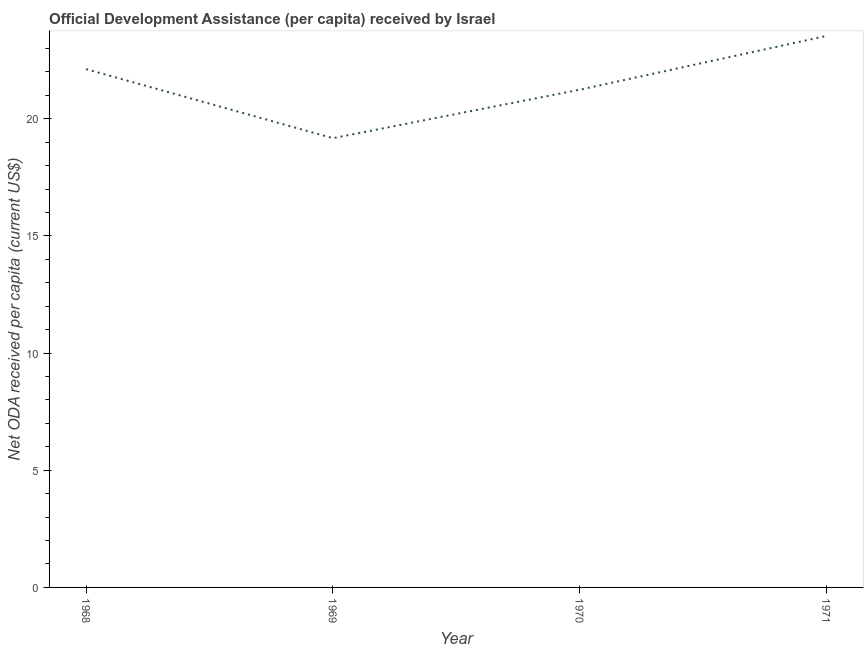What is the net oda received per capita in 1970?
Your response must be concise. 21.24. Across all years, what is the maximum net oda received per capita?
Give a very brief answer. 23.53. Across all years, what is the minimum net oda received per capita?
Give a very brief answer. 19.17. In which year was the net oda received per capita maximum?
Keep it short and to the point. 1971. In which year was the net oda received per capita minimum?
Offer a very short reply. 1969. What is the sum of the net oda received per capita?
Offer a terse response. 86.05. What is the difference between the net oda received per capita in 1969 and 1970?
Ensure brevity in your answer.  -2.07. What is the average net oda received per capita per year?
Offer a very short reply. 21.51. What is the median net oda received per capita?
Your answer should be compact. 21.68. In how many years, is the net oda received per capita greater than 1 US$?
Ensure brevity in your answer.  4. What is the ratio of the net oda received per capita in 1969 to that in 1970?
Your response must be concise. 0.9. What is the difference between the highest and the second highest net oda received per capita?
Keep it short and to the point. 1.42. What is the difference between the highest and the lowest net oda received per capita?
Make the answer very short. 4.36. In how many years, is the net oda received per capita greater than the average net oda received per capita taken over all years?
Keep it short and to the point. 2. What is the difference between two consecutive major ticks on the Y-axis?
Offer a terse response. 5. Are the values on the major ticks of Y-axis written in scientific E-notation?
Provide a short and direct response. No. What is the title of the graph?
Offer a very short reply. Official Development Assistance (per capita) received by Israel. What is the label or title of the X-axis?
Offer a terse response. Year. What is the label or title of the Y-axis?
Your answer should be very brief. Net ODA received per capita (current US$). What is the Net ODA received per capita (current US$) of 1968?
Offer a terse response. 22.12. What is the Net ODA received per capita (current US$) in 1969?
Offer a terse response. 19.17. What is the Net ODA received per capita (current US$) in 1970?
Keep it short and to the point. 21.24. What is the Net ODA received per capita (current US$) in 1971?
Ensure brevity in your answer.  23.53. What is the difference between the Net ODA received per capita (current US$) in 1968 and 1969?
Give a very brief answer. 2.95. What is the difference between the Net ODA received per capita (current US$) in 1968 and 1970?
Ensure brevity in your answer.  0.88. What is the difference between the Net ODA received per capita (current US$) in 1968 and 1971?
Offer a very short reply. -1.42. What is the difference between the Net ODA received per capita (current US$) in 1969 and 1970?
Your response must be concise. -2.07. What is the difference between the Net ODA received per capita (current US$) in 1969 and 1971?
Provide a short and direct response. -4.36. What is the difference between the Net ODA received per capita (current US$) in 1970 and 1971?
Keep it short and to the point. -2.29. What is the ratio of the Net ODA received per capita (current US$) in 1968 to that in 1969?
Ensure brevity in your answer.  1.15. What is the ratio of the Net ODA received per capita (current US$) in 1968 to that in 1970?
Your response must be concise. 1.04. What is the ratio of the Net ODA received per capita (current US$) in 1968 to that in 1971?
Ensure brevity in your answer.  0.94. What is the ratio of the Net ODA received per capita (current US$) in 1969 to that in 1970?
Ensure brevity in your answer.  0.9. What is the ratio of the Net ODA received per capita (current US$) in 1969 to that in 1971?
Offer a terse response. 0.81. What is the ratio of the Net ODA received per capita (current US$) in 1970 to that in 1971?
Your answer should be compact. 0.9. 